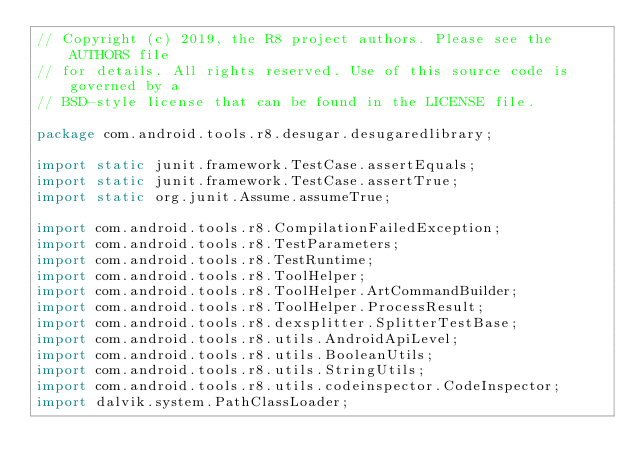<code> <loc_0><loc_0><loc_500><loc_500><_Java_>// Copyright (c) 2019, the R8 project authors. Please see the AUTHORS file
// for details. All rights reserved. Use of this source code is governed by a
// BSD-style license that can be found in the LICENSE file.

package com.android.tools.r8.desugar.desugaredlibrary;

import static junit.framework.TestCase.assertEquals;
import static junit.framework.TestCase.assertTrue;
import static org.junit.Assume.assumeTrue;

import com.android.tools.r8.CompilationFailedException;
import com.android.tools.r8.TestParameters;
import com.android.tools.r8.TestRuntime;
import com.android.tools.r8.ToolHelper;
import com.android.tools.r8.ToolHelper.ArtCommandBuilder;
import com.android.tools.r8.ToolHelper.ProcessResult;
import com.android.tools.r8.dexsplitter.SplitterTestBase;
import com.android.tools.r8.utils.AndroidApiLevel;
import com.android.tools.r8.utils.BooleanUtils;
import com.android.tools.r8.utils.StringUtils;
import com.android.tools.r8.utils.codeinspector.CodeInspector;
import dalvik.system.PathClassLoader;</code> 